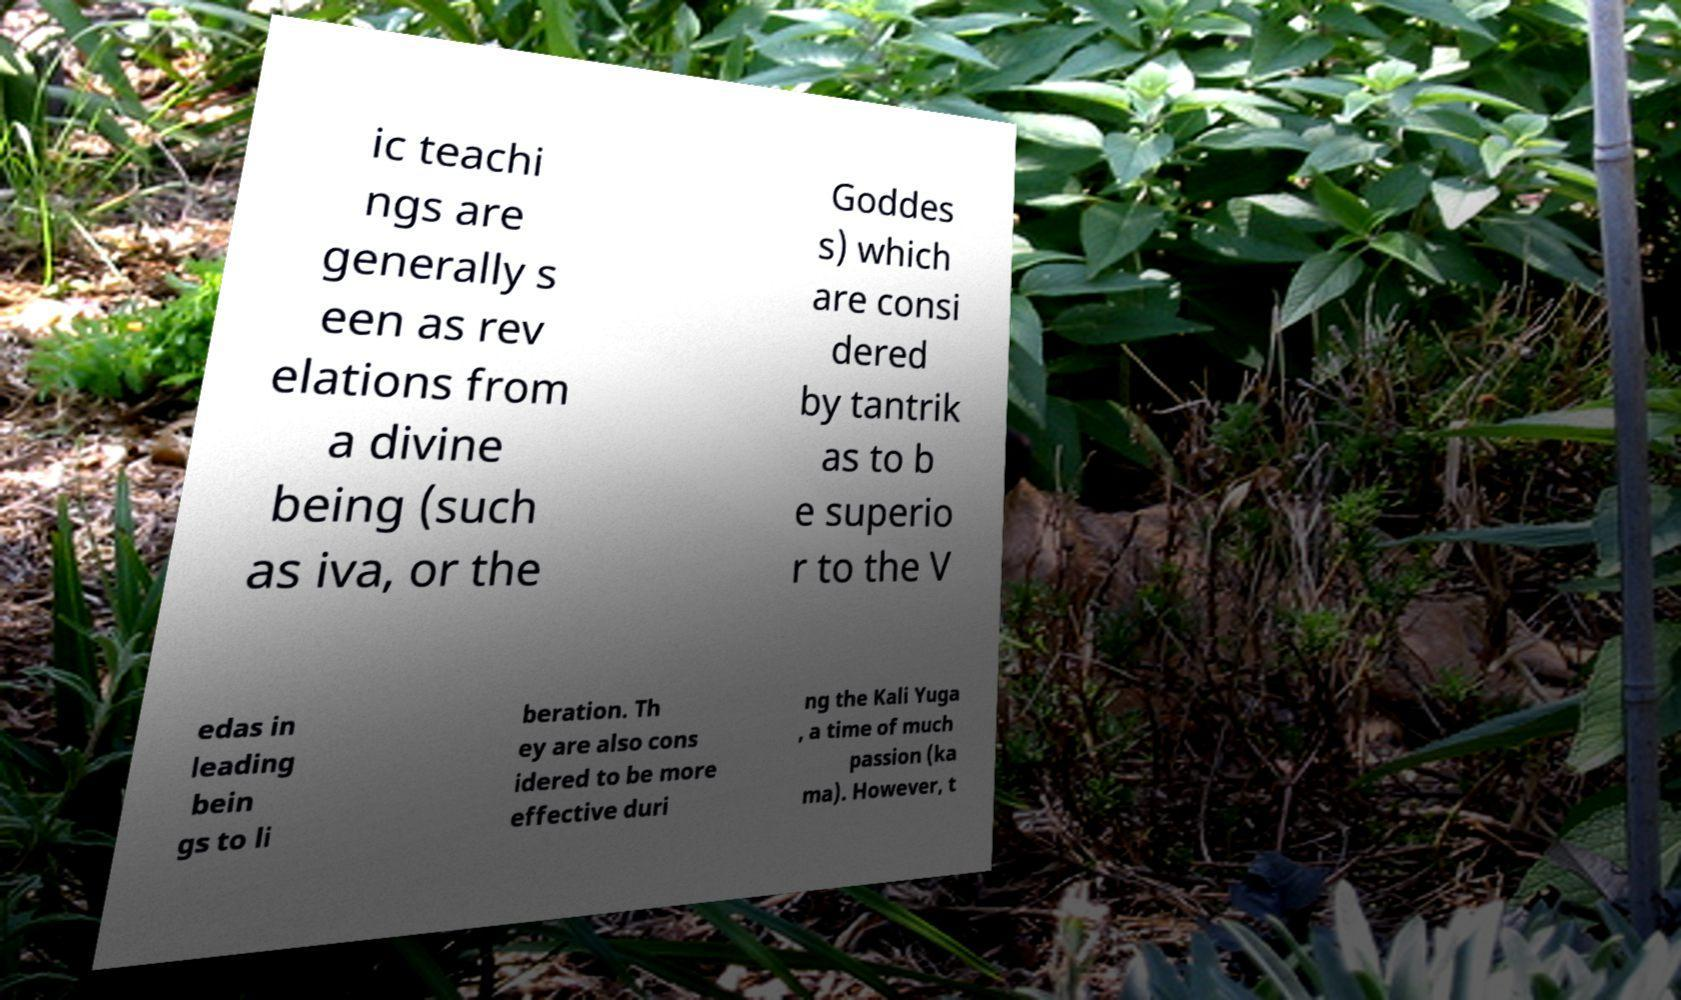Can you read and provide the text displayed in the image?This photo seems to have some interesting text. Can you extract and type it out for me? ic teachi ngs are generally s een as rev elations from a divine being (such as iva, or the Goddes s) which are consi dered by tantrik as to b e superio r to the V edas in leading bein gs to li beration. Th ey are also cons idered to be more effective duri ng the Kali Yuga , a time of much passion (ka ma). However, t 